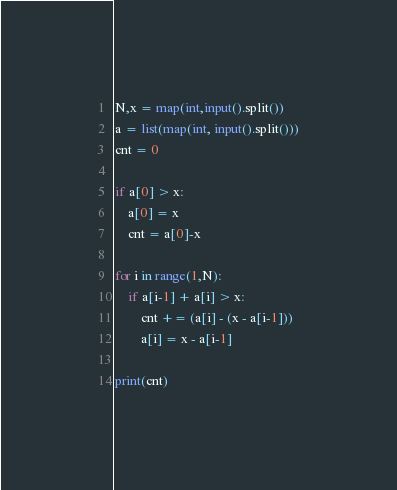Convert code to text. <code><loc_0><loc_0><loc_500><loc_500><_Python_>N,x = map(int,input().split())
a = list(map(int, input().split()))
cnt = 0

if a[0] > x:
    a[0] = x
    cnt = a[0]-x

for i in range(1,N):
    if a[i-1] + a[i] > x:
        cnt += (a[i] - (x - a[i-1]))
        a[i] = x - a[i-1]
        
print(cnt)</code> 